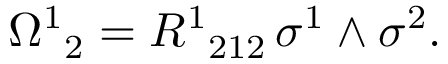<formula> <loc_0><loc_0><loc_500><loc_500>{ \Omega ^ { 1 } } _ { 2 } = { R ^ { 1 } } _ { 2 1 2 } \, \sigma ^ { 1 } \wedge \sigma ^ { 2 } .</formula> 